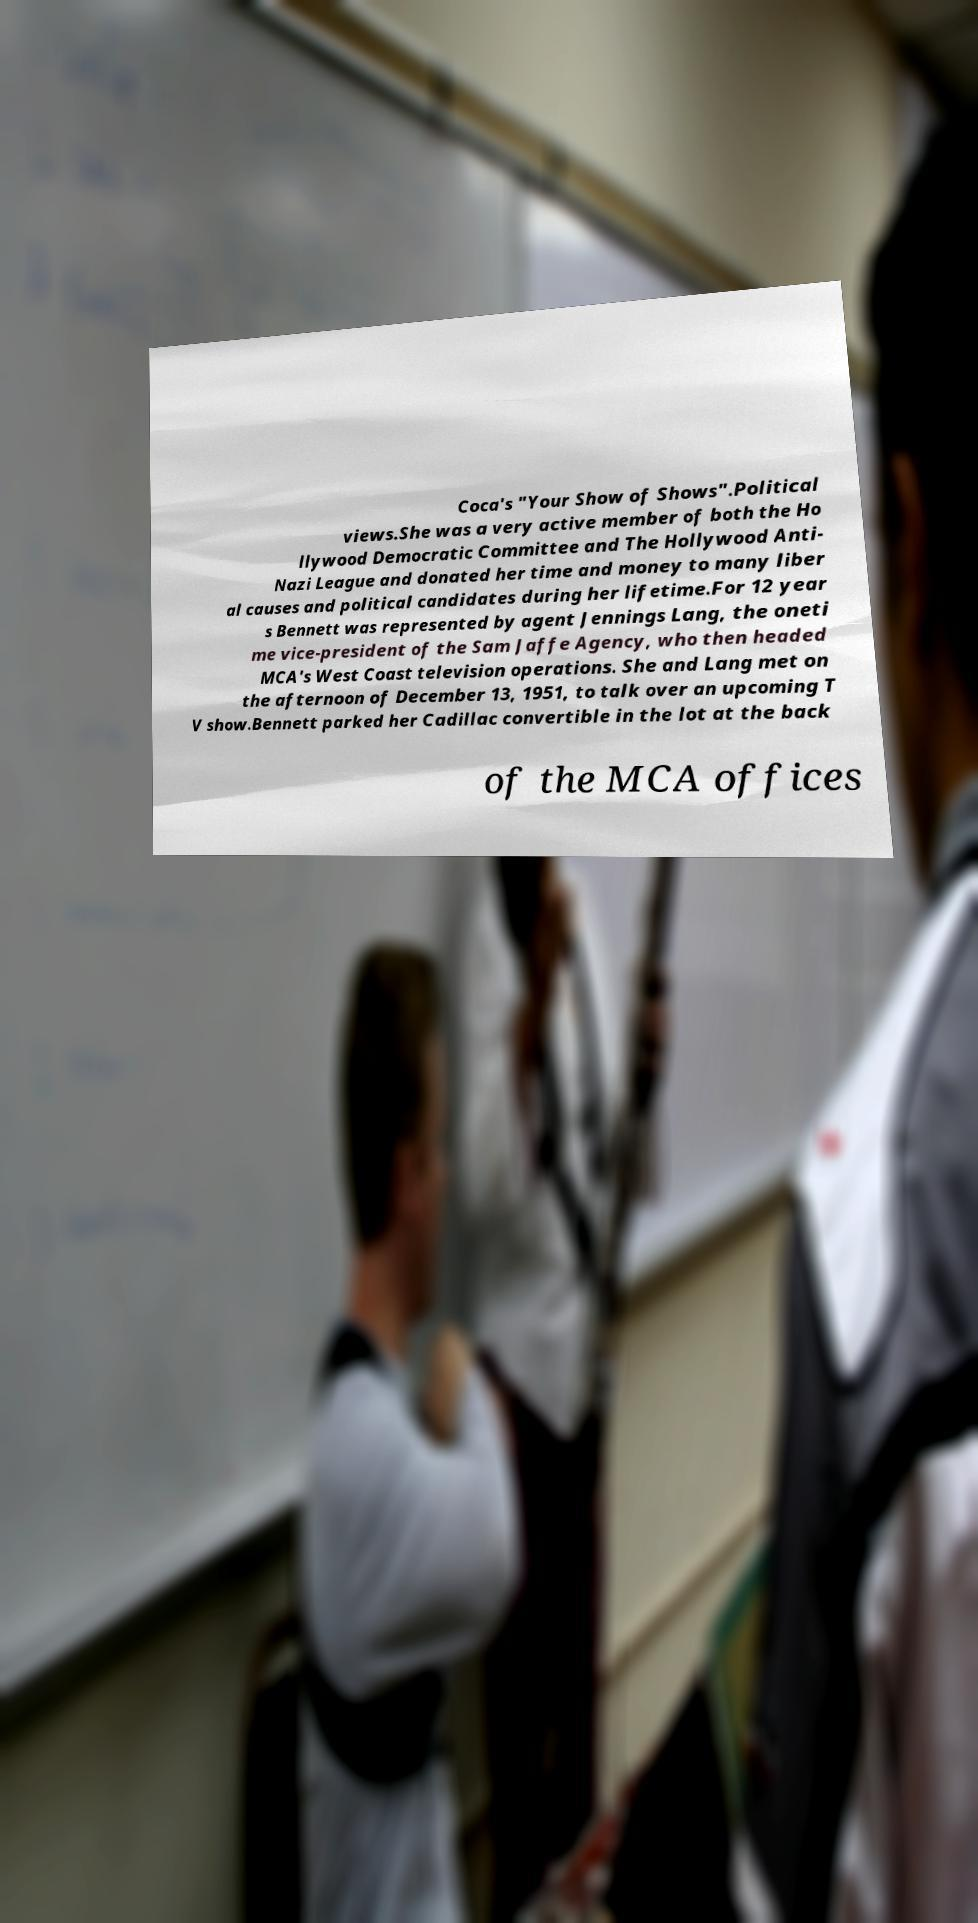I need the written content from this picture converted into text. Can you do that? Coca's "Your Show of Shows".Political views.She was a very active member of both the Ho llywood Democratic Committee and The Hollywood Anti- Nazi League and donated her time and money to many liber al causes and political candidates during her lifetime.For 12 year s Bennett was represented by agent Jennings Lang, the oneti me vice-president of the Sam Jaffe Agency, who then headed MCA's West Coast television operations. She and Lang met on the afternoon of December 13, 1951, to talk over an upcoming T V show.Bennett parked her Cadillac convertible in the lot at the back of the MCA offices 